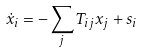Convert formula to latex. <formula><loc_0><loc_0><loc_500><loc_500>\dot { x } _ { i } = - \sum _ { j } T _ { i j } x _ { j } + s _ { i }</formula> 